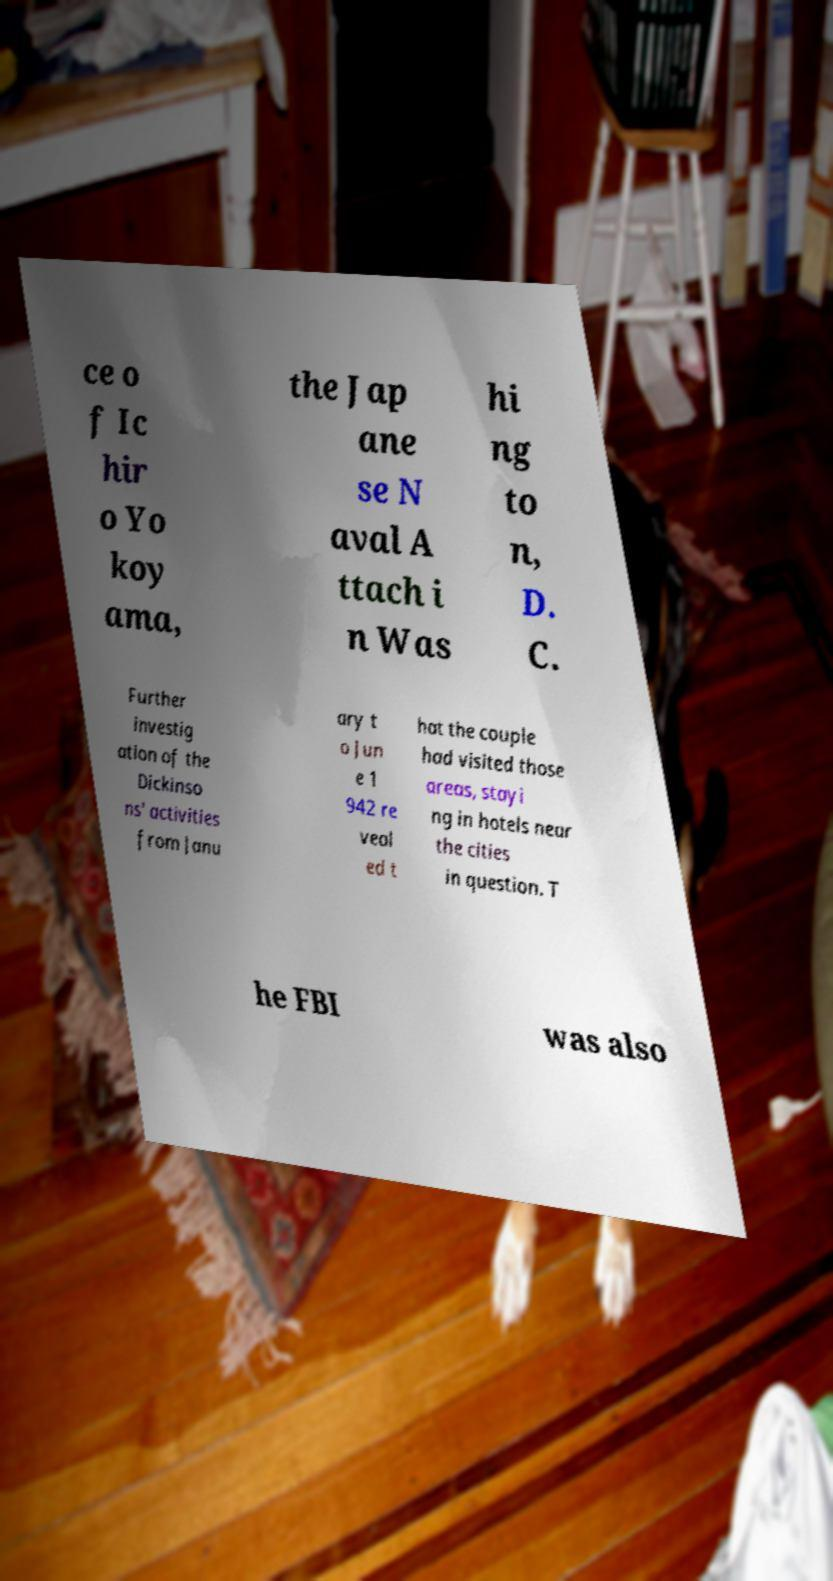Can you accurately transcribe the text from the provided image for me? ce o f Ic hir o Yo koy ama, the Jap ane se N aval A ttach i n Was hi ng to n, D. C. Further investig ation of the Dickinso ns' activities from Janu ary t o Jun e 1 942 re veal ed t hat the couple had visited those areas, stayi ng in hotels near the cities in question. T he FBI was also 